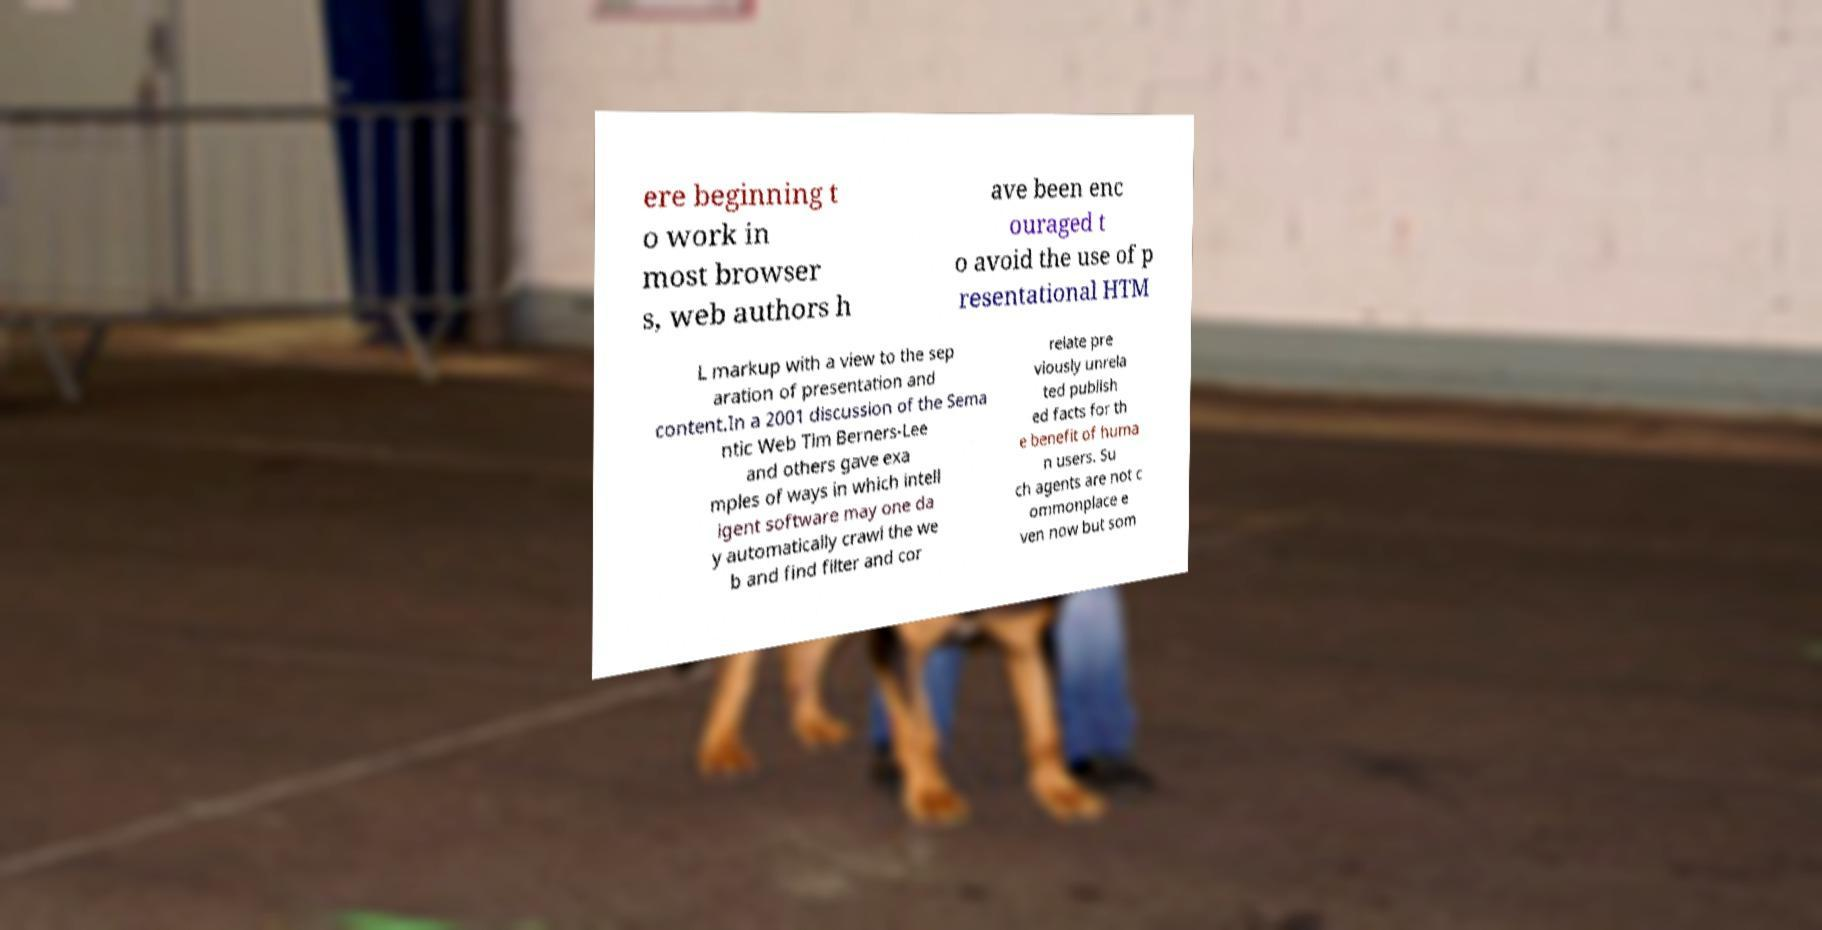Can you accurately transcribe the text from the provided image for me? ere beginning t o work in most browser s, web authors h ave been enc ouraged t o avoid the use of p resentational HTM L markup with a view to the sep aration of presentation and content.In a 2001 discussion of the Sema ntic Web Tim Berners-Lee and others gave exa mples of ways in which intell igent software may one da y automatically crawl the we b and find filter and cor relate pre viously unrela ted publish ed facts for th e benefit of huma n users. Su ch agents are not c ommonplace e ven now but som 